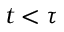<formula> <loc_0><loc_0><loc_500><loc_500>t < \tau</formula> 